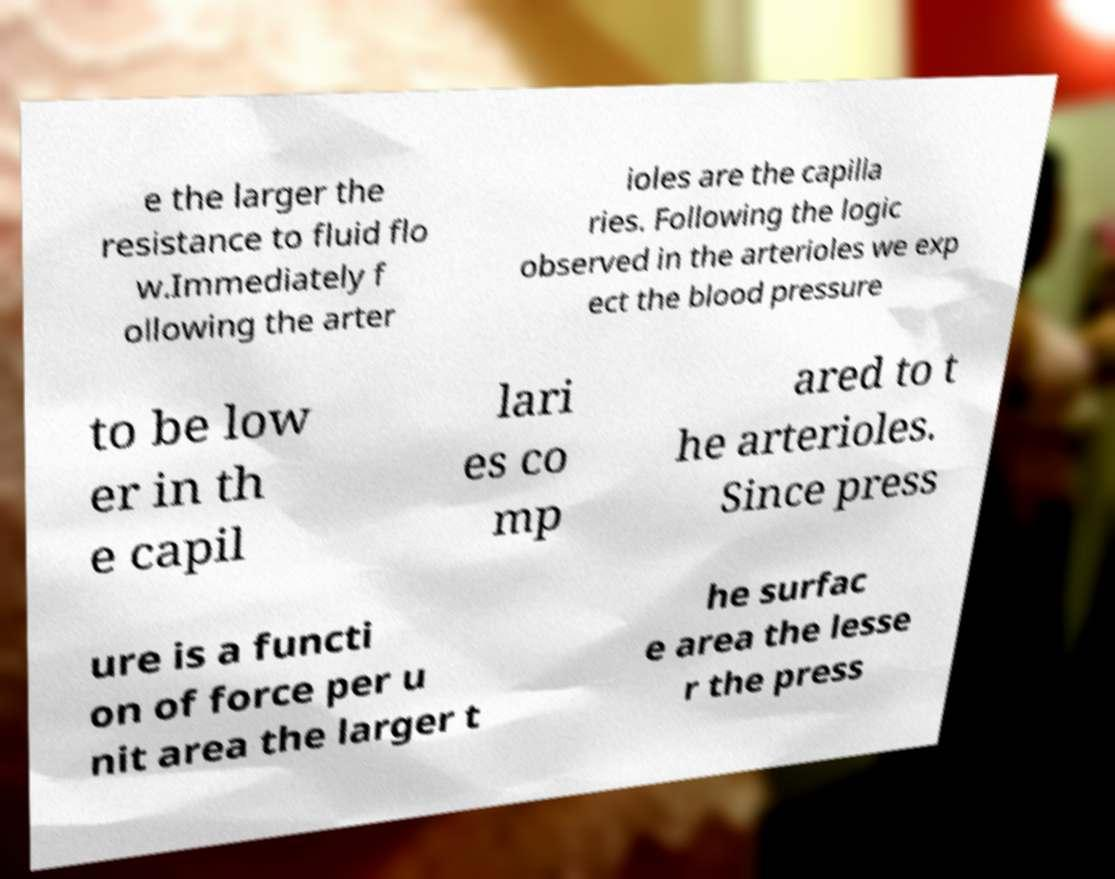Please identify and transcribe the text found in this image. e the larger the resistance to fluid flo w.Immediately f ollowing the arter ioles are the capilla ries. Following the logic observed in the arterioles we exp ect the blood pressure to be low er in th e capil lari es co mp ared to t he arterioles. Since press ure is a functi on of force per u nit area the larger t he surfac e area the lesse r the press 